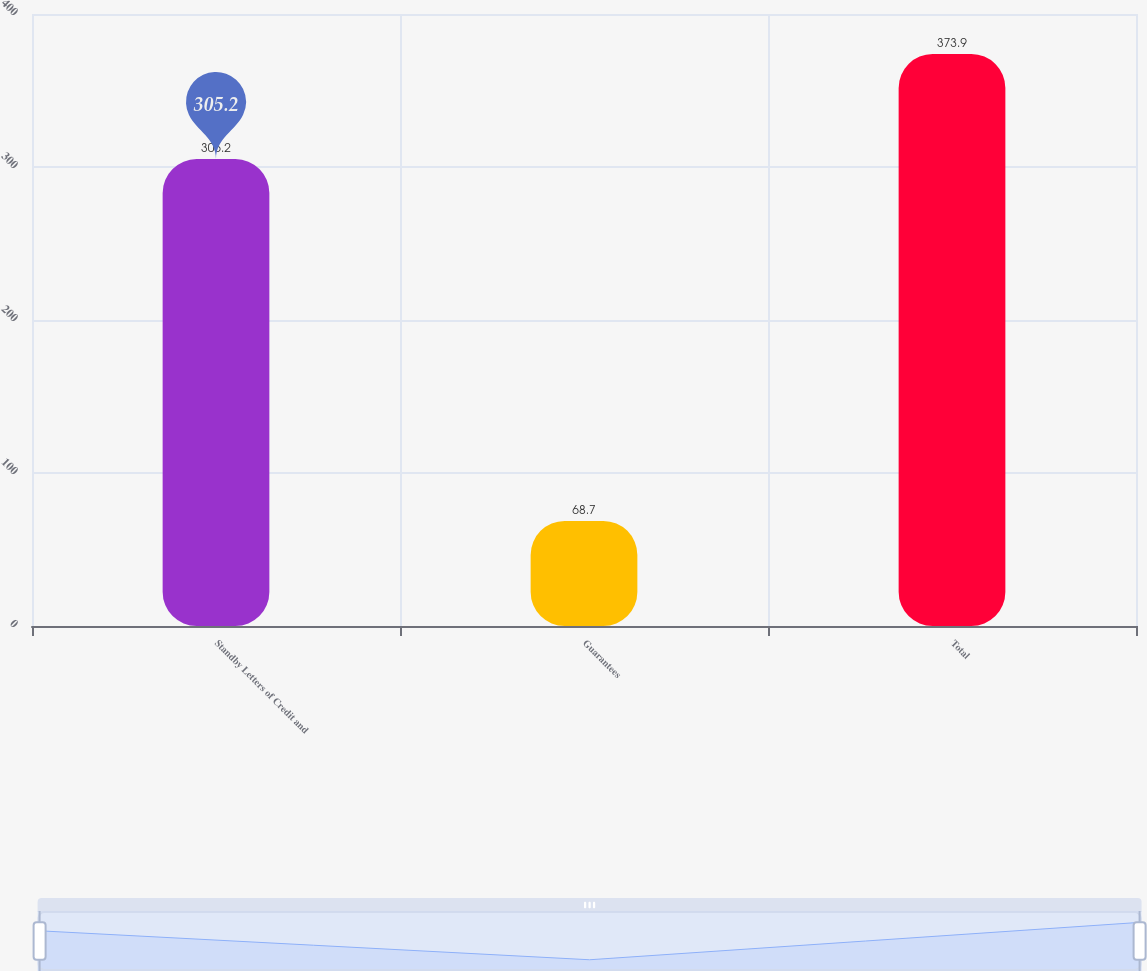Convert chart. <chart><loc_0><loc_0><loc_500><loc_500><bar_chart><fcel>Standby Letters of Credit and<fcel>Guarantees<fcel>Total<nl><fcel>305.2<fcel>68.7<fcel>373.9<nl></chart> 